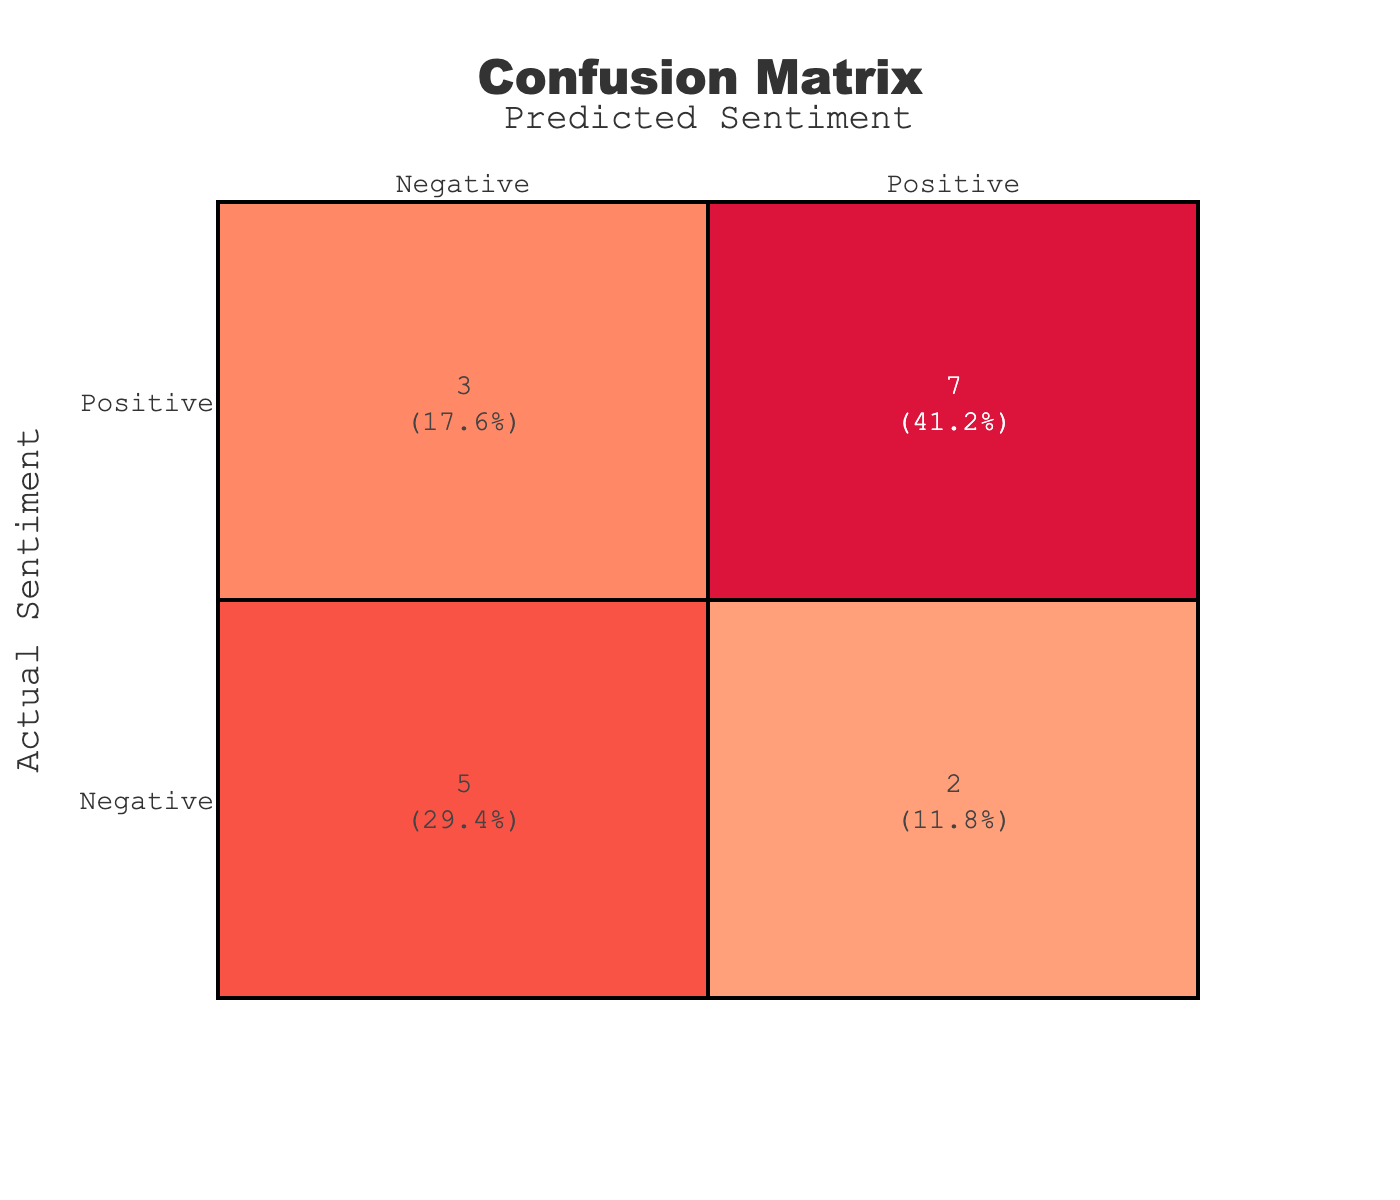What is the total number of reviews analyzed? By adding up all the values in the confusion matrix, we get the total number of reviews. The counts are: 5 Positive/Positive, 2 Positive/Negative, 2 Negative/Positive, and 5 Negative/Negative. Therefore, total = 5 + 2 + 2 + 5 = 14 reviews.
Answer: 14 What is the accuracy of the sentiment prediction? Accuracy is calculated as the sum of true positives and true negatives divided by the total number of reviews. In this case: (5 Positive/Positive + 5 Negative/Negative) / 14 = 10 / 14 = approximately 0.7143. Therefore, the accuracy is 71.43%.
Answer: 71.43% How many times were negative reviews incorrectly predicted as positive? This is identified in the table as the count in the Negative/Positive cell. Referring to the confusion matrix, we see that there are 2 instances where Negative reviews were incorrectly predicted as Positive.
Answer: 2 Is the number of actual negative sentiments predicted correctly greater than the actual positive sentiments predicted correctly? The counts are 5 for Negative/Negative and 5 for Positive/Positive, which means both are equal. Since they are not greater, the statement is false.
Answer: No How many false positives are there in total? False positives are recorded in the Positive/Negative and Negative/Positive cells of the confusion matrix. The false positives are the reviews for Negative sentiment incorrectly predicted as Positive, which totals to 2. Therefore, the total false positives is 2.
Answer: 2 What is the percentage of reviews that were categorized as Negative? To calculate the percentage of Negative sentiments, we look at both Negative/Positive and Negative/Negative counts. So, the total for Negative is 2 + 5 = 7. The percentage is then (7 / 14) * 100 = 50%.
Answer: 50% What is the difference between the number of true positives and true negatives? True positives are in the Positive/Positive cell (5), while true negatives are in the Negative/Negative cell (5). The difference is calculated as 5 - 5 = 0.
Answer: 0 What fraction of all predictions were incorrect predictions? Incorrect predictions are the sum of Positive/Negative and Negative/Positive counts, giving us 2 + 2 = 4. Therefore, the fraction is 4 incorrect predictions out of 14 total predictions, which is 4/14 and simplifies to 2/7.
Answer: 2/7 